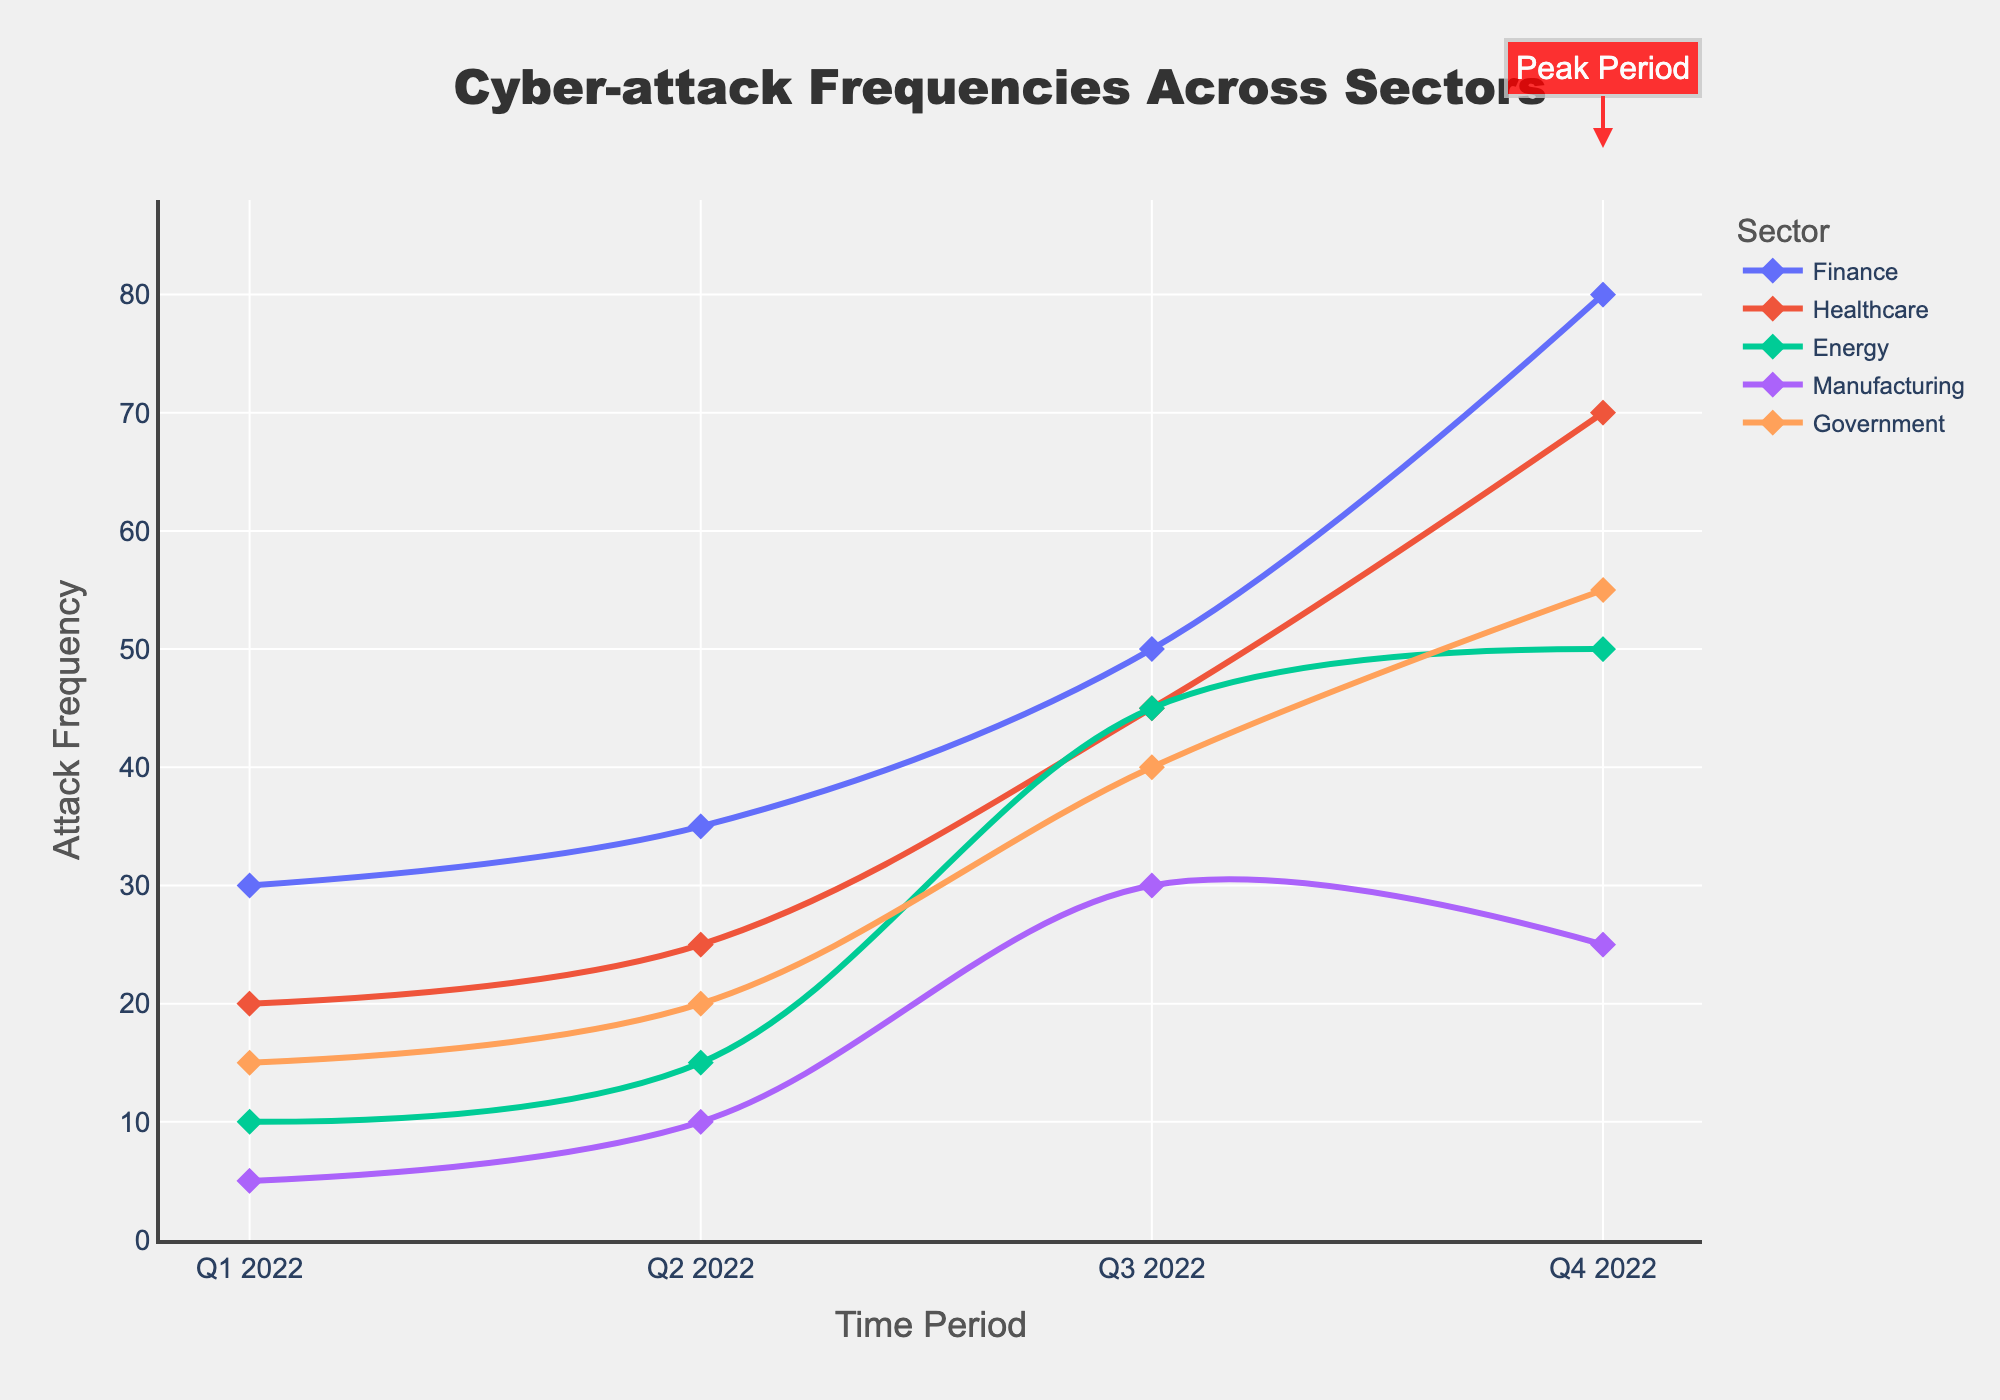What is the title of the figure? The title can usually be found at the top of the figure, and it provides a summary of what the figure represents. Here, the title reads "Cyber-attack Frequencies Across Sectors".
Answer: Cyber-attack Frequencies Across Sectors Which sector had the highest attack frequency in Q4 2022? Look at the data points for Q4 2022 and compare the attack frequencies across all sectors. The Finance sector had the highest attack frequency in Q4 2022 with around 80 attacks.
Answer: Finance What is the peak period of cyber-attacks across all sectors? The peak period is annotated and shaded on the plot. The shaded area and annotation indicate that the peak period is Q4 2022.
Answer: Q4 2022 How did the attack frequency for the Manufacturing sector change from Q1 to Q4 in 2022? Trace the line representing the Manufacturing sector from Q1 to Q4 2022, noting the attack frequencies at each point. The attack frequency increased from 5 in Q1 to 25 in Q4.
Answer: Increased Which sector showed the least variability in attack frequencies over the time period? Evaluate the lines for each sector. The Energy sector line shows relatively little fluctuation, indicating the least variability in attack frequencies.
Answer: Energy What was the average attack frequency for the Healthcare sector in 2022? Add the attack frequencies for Healthcare in each quarter (20+25+45+70 = 160) and divide by the number of quarters (4). The average is 160 / 4 = 40.
Answer: 40 In which quarter did the Government sector experience a significant increase in attacks? Examine the line representing the Government sector. The significant increase is between Q3 and Q4, where the frequency jumped from 40 to 55.
Answer: Between Q3 and Q4 Compare the attack frequency trend for the Finance and Energy sectors. Which sector had a steeper increase towards the end of the year? Look at the slope of each line towards Q4 2022. The Finance sector shows a steeper increase compared to the Energy sector in the final quarter.
Answer: Finance During which quarter did most sectors experience an upward trend in attack frequencies? Look for a common upward movement in the lines for most sectors. In Q4 2022, most sectors show an increase in attack frequencies.
Answer: Q4 2022 